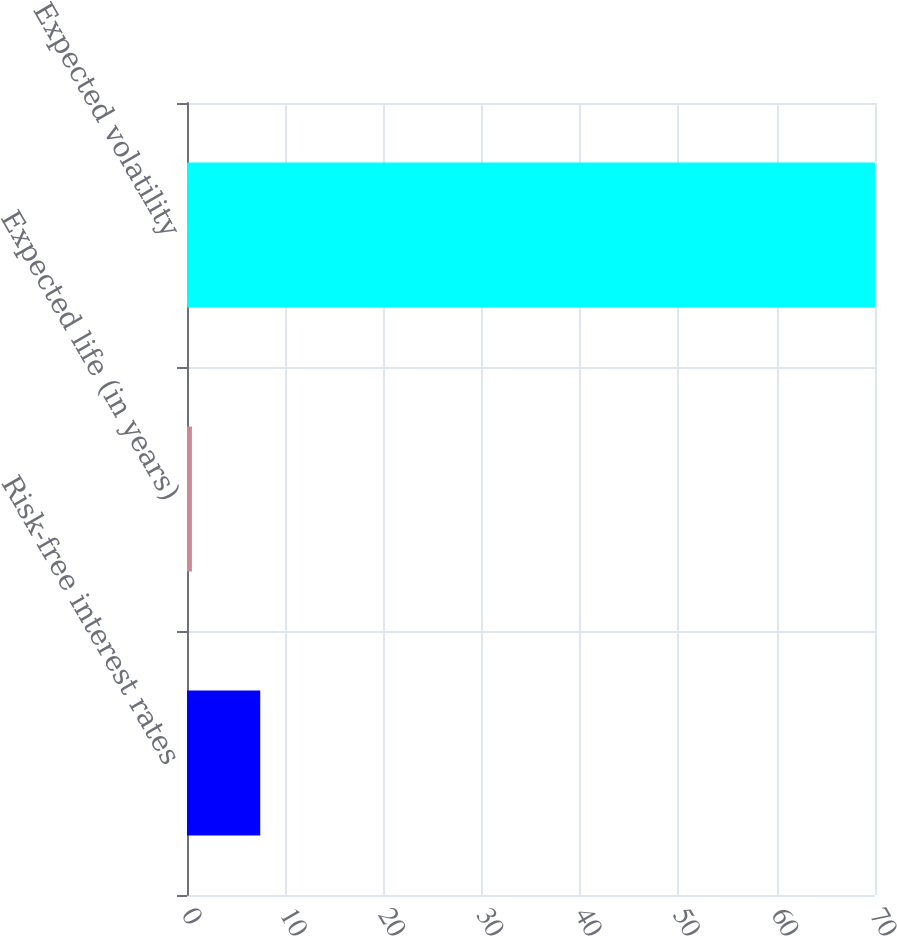Convert chart to OTSL. <chart><loc_0><loc_0><loc_500><loc_500><bar_chart><fcel>Risk-free interest rates<fcel>Expected life (in years)<fcel>Expected volatility<nl><fcel>7.45<fcel>0.5<fcel>70<nl></chart> 